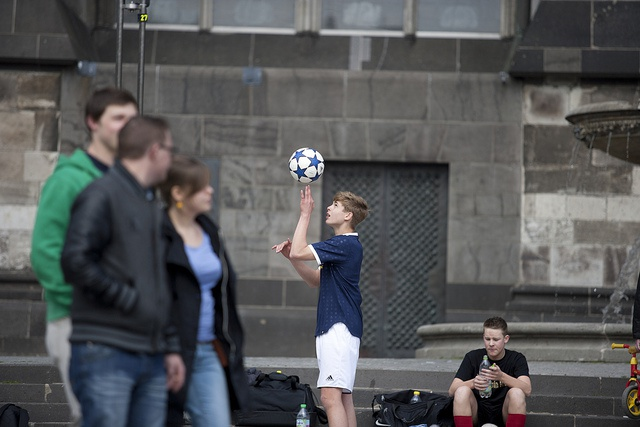Describe the objects in this image and their specific colors. I can see people in black, gray, and darkblue tones, people in black, gray, and darkgray tones, people in black, navy, lavender, and gray tones, people in black, teal, gray, and darkgray tones, and people in black, darkgray, and gray tones in this image. 